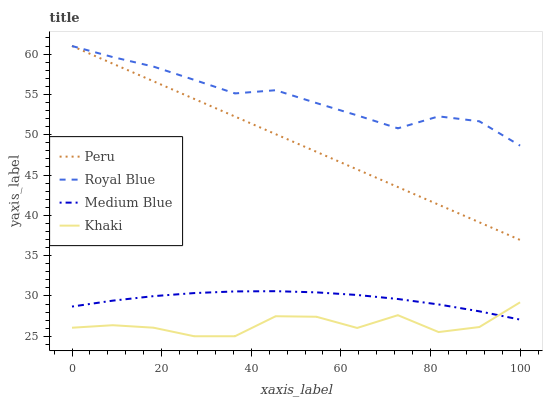Does Khaki have the minimum area under the curve?
Answer yes or no. Yes. Does Royal Blue have the maximum area under the curve?
Answer yes or no. Yes. Does Medium Blue have the minimum area under the curve?
Answer yes or no. No. Does Medium Blue have the maximum area under the curve?
Answer yes or no. No. Is Peru the smoothest?
Answer yes or no. Yes. Is Khaki the roughest?
Answer yes or no. Yes. Is Medium Blue the smoothest?
Answer yes or no. No. Is Medium Blue the roughest?
Answer yes or no. No. Does Khaki have the lowest value?
Answer yes or no. Yes. Does Medium Blue have the lowest value?
Answer yes or no. No. Does Peru have the highest value?
Answer yes or no. Yes. Does Medium Blue have the highest value?
Answer yes or no. No. Is Khaki less than Peru?
Answer yes or no. Yes. Is Royal Blue greater than Medium Blue?
Answer yes or no. Yes. Does Khaki intersect Medium Blue?
Answer yes or no. Yes. Is Khaki less than Medium Blue?
Answer yes or no. No. Is Khaki greater than Medium Blue?
Answer yes or no. No. Does Khaki intersect Peru?
Answer yes or no. No. 